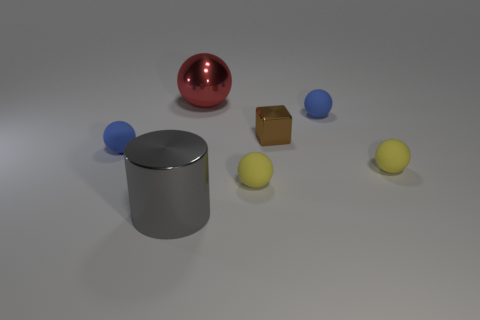Are there any other things that are the same shape as the brown thing?
Your response must be concise. No. There is a tiny yellow object in front of the small yellow thing behind the tiny yellow ball that is on the left side of the tiny metal block; what shape is it?
Your response must be concise. Sphere. Are there fewer yellow matte objects that are behind the brown block than small blue matte spheres that are left of the metal ball?
Your answer should be very brief. Yes. Does the small brown object have the same material as the yellow ball to the right of the small cube?
Your answer should be compact. No. Are there any blue rubber balls that are on the right side of the blue matte ball that is left of the red shiny sphere?
Make the answer very short. Yes. What is the color of the small sphere that is both in front of the small shiny cube and to the right of the small brown metallic block?
Your response must be concise. Yellow. The brown block is what size?
Provide a short and direct response. Small. How many objects are the same size as the metal ball?
Your answer should be compact. 1. Do the small blue ball that is on the right side of the cube and the big object that is behind the cube have the same material?
Ensure brevity in your answer.  No. The big object behind the blue rubber ball right of the block is made of what material?
Keep it short and to the point. Metal. 